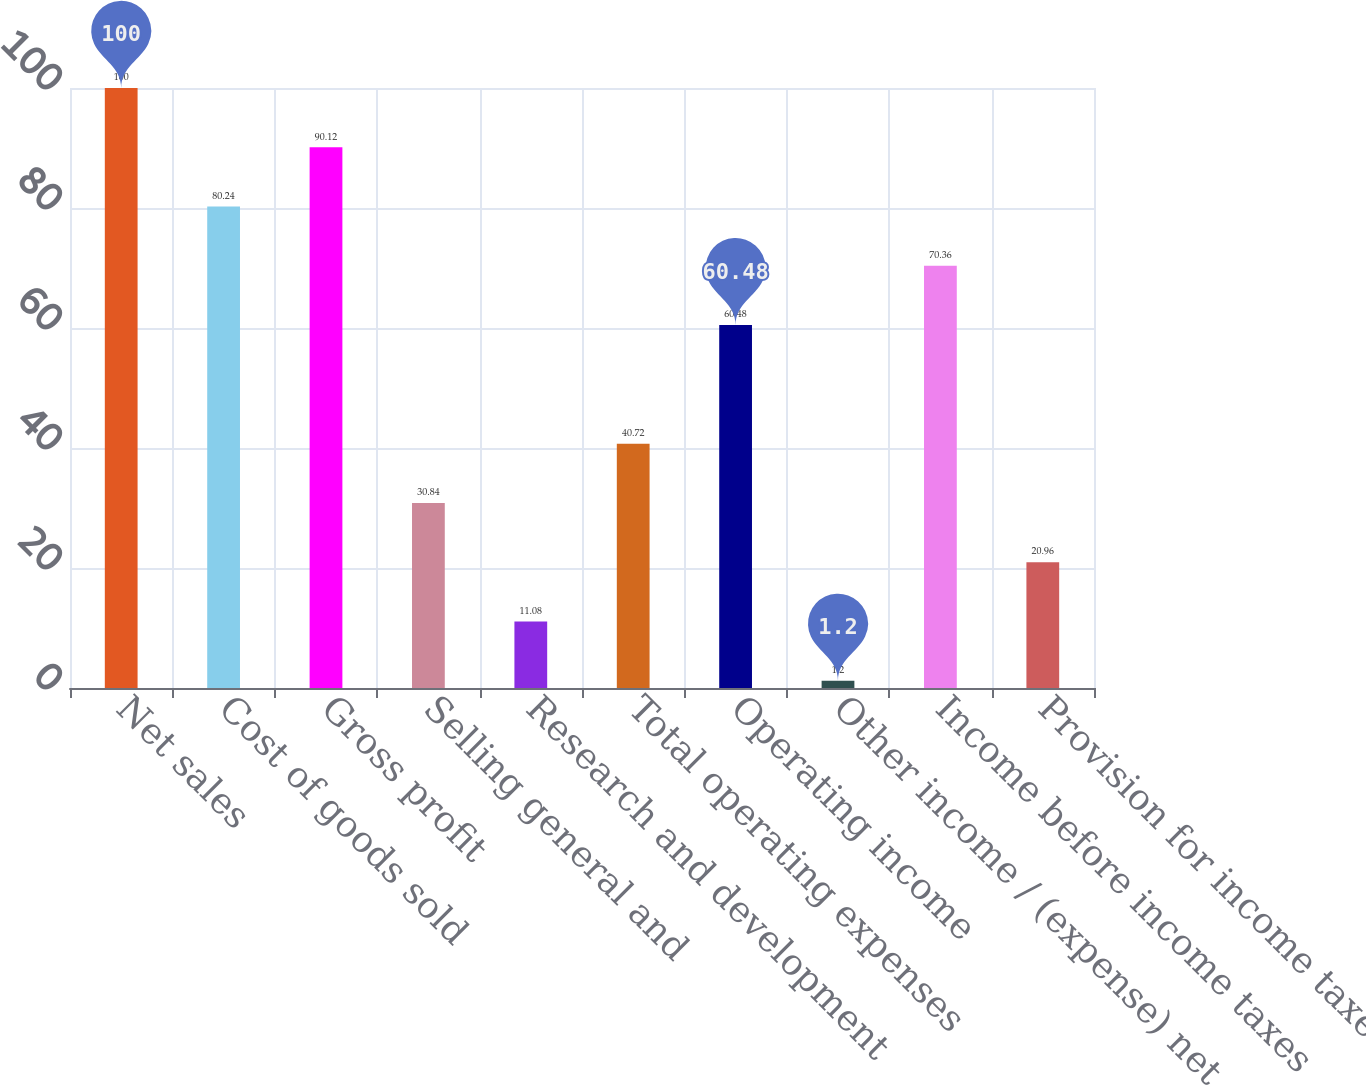<chart> <loc_0><loc_0><loc_500><loc_500><bar_chart><fcel>Net sales<fcel>Cost of goods sold<fcel>Gross profit<fcel>Selling general and<fcel>Research and development<fcel>Total operating expenses<fcel>Operating income<fcel>Other income / (expense) net<fcel>Income before income taxes<fcel>Provision for income taxes<nl><fcel>100<fcel>80.24<fcel>90.12<fcel>30.84<fcel>11.08<fcel>40.72<fcel>60.48<fcel>1.2<fcel>70.36<fcel>20.96<nl></chart> 